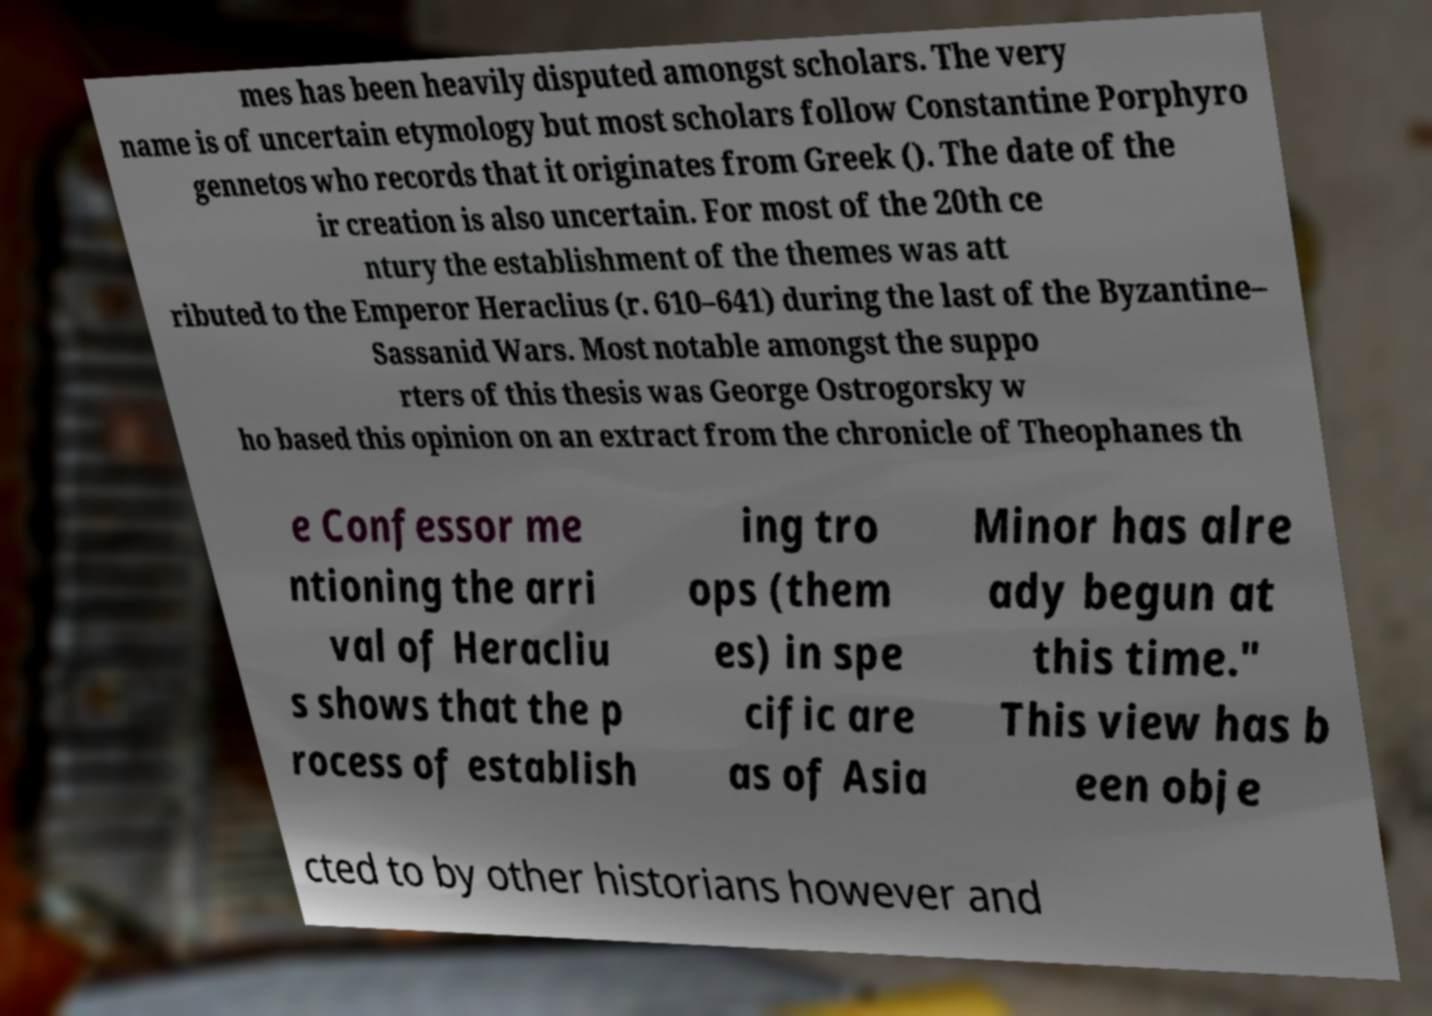What messages or text are displayed in this image? I need them in a readable, typed format. mes has been heavily disputed amongst scholars. The very name is of uncertain etymology but most scholars follow Constantine Porphyro gennetos who records that it originates from Greek (). The date of the ir creation is also uncertain. For most of the 20th ce ntury the establishment of the themes was att ributed to the Emperor Heraclius (r. 610–641) during the last of the Byzantine– Sassanid Wars. Most notable amongst the suppo rters of this thesis was George Ostrogorsky w ho based this opinion on an extract from the chronicle of Theophanes th e Confessor me ntioning the arri val of Heracliu s shows that the p rocess of establish ing tro ops (them es) in spe cific are as of Asia Minor has alre ady begun at this time." This view has b een obje cted to by other historians however and 